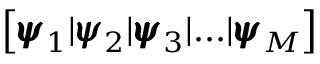Convert formula to latex. <formula><loc_0><loc_0><loc_500><loc_500>\left [ { \pm b { \psi } } _ { 1 } | { \pm b { \psi } } _ { 2 } | { \pm b { \psi } } _ { 3 } | \dots | { \pm b { \psi } } _ { M } \right ]</formula> 